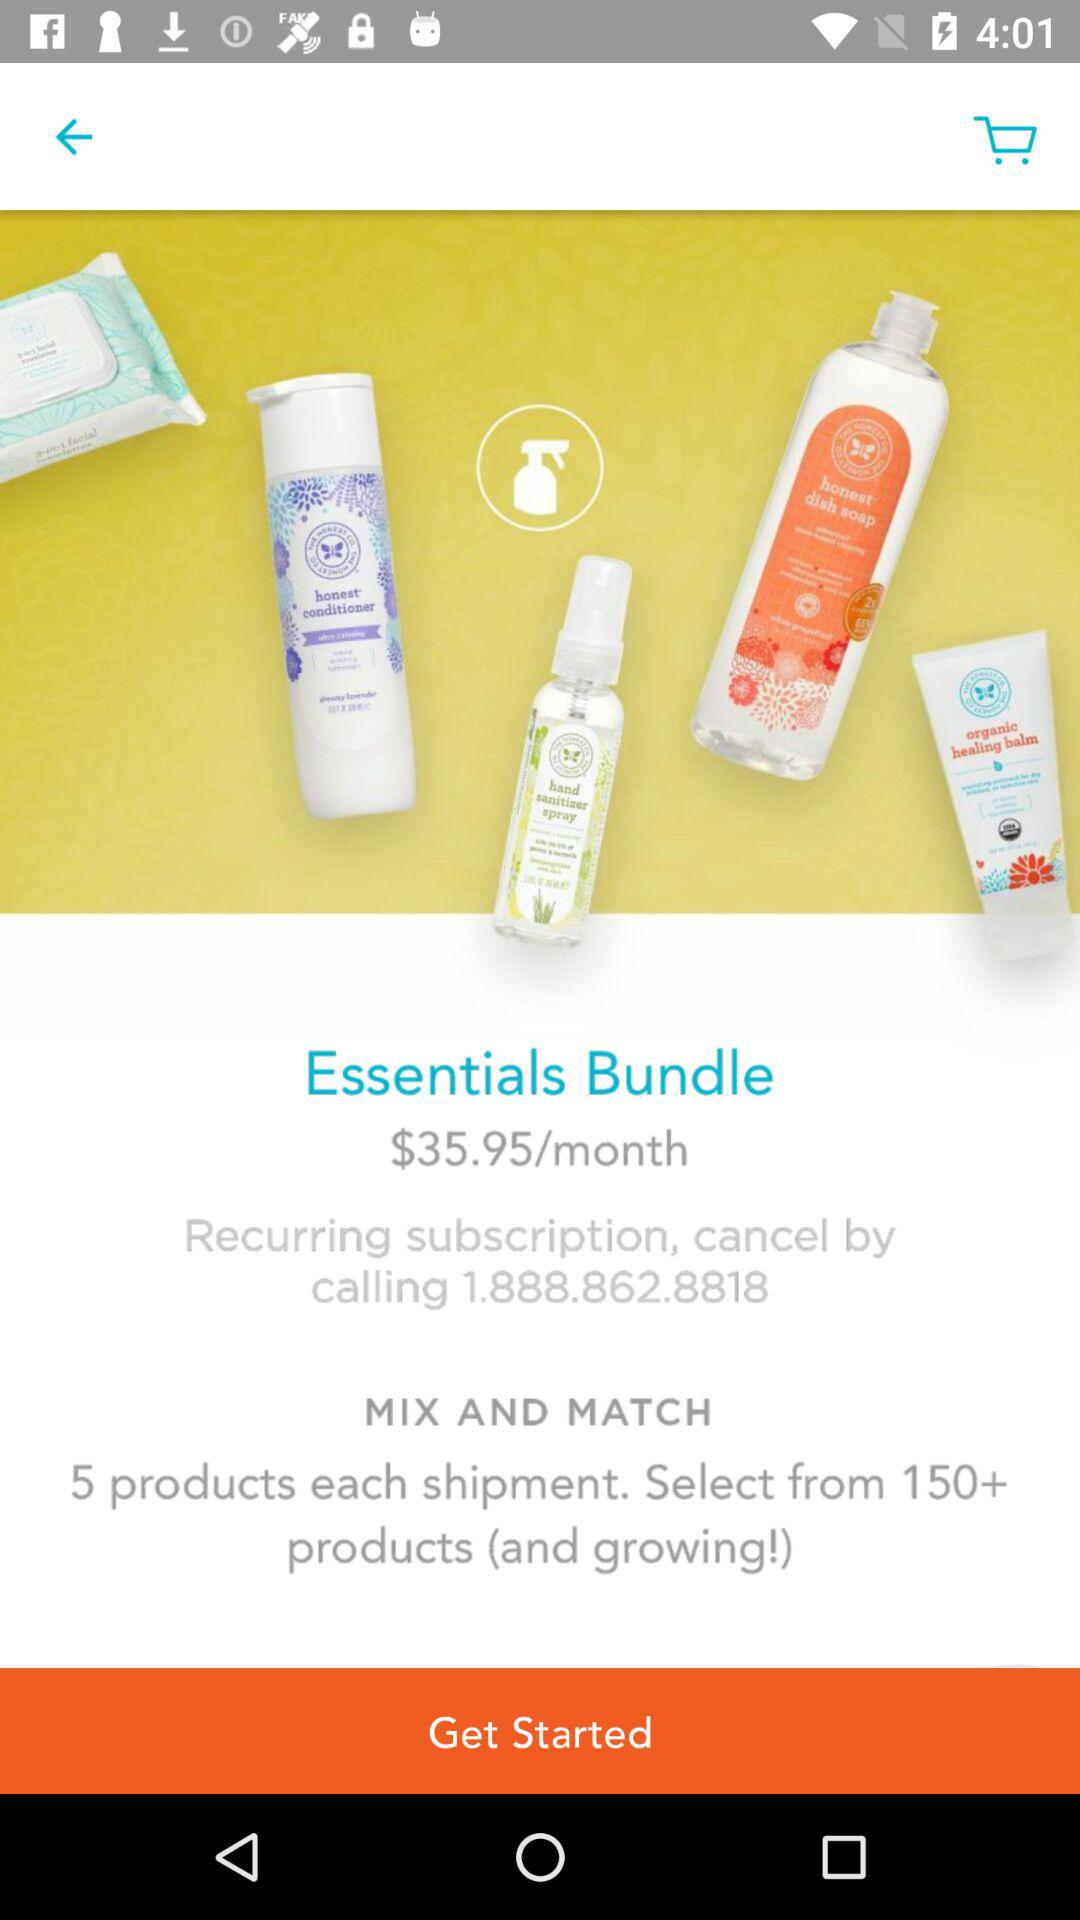How many products can I choose from for the Essentials Bundle?
Answer the question using a single word or phrase. 150+ 